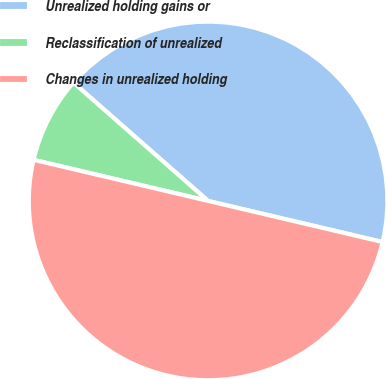<chart> <loc_0><loc_0><loc_500><loc_500><pie_chart><fcel>Unrealized holding gains or<fcel>Reclassification of unrealized<fcel>Changes in unrealized holding<nl><fcel>42.21%<fcel>7.79%<fcel>50.0%<nl></chart> 